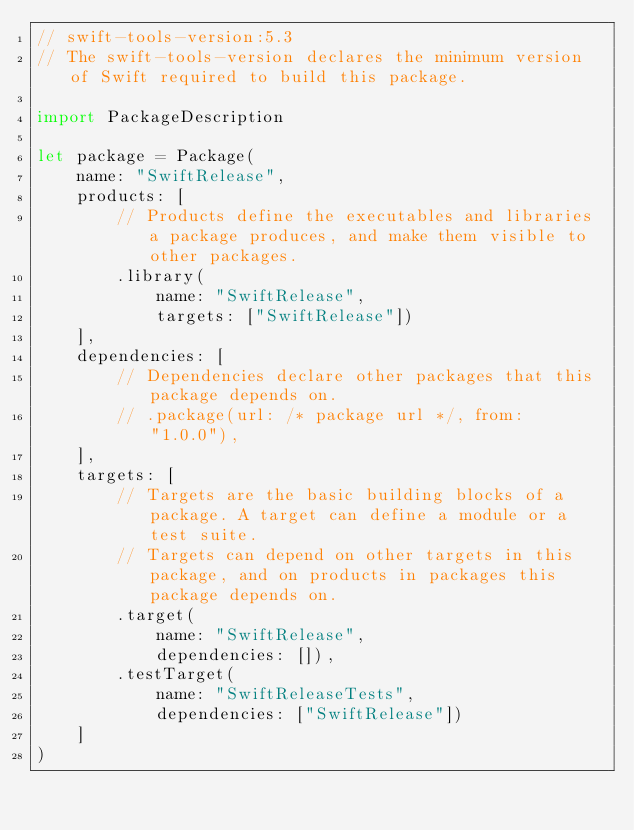Convert code to text. <code><loc_0><loc_0><loc_500><loc_500><_Swift_>// swift-tools-version:5.3
// The swift-tools-version declares the minimum version of Swift required to build this package.

import PackageDescription

let package = Package(
    name: "SwiftRelease",
    products: [
        // Products define the executables and libraries a package produces, and make them visible to other packages.
        .library(
            name: "SwiftRelease",
            targets: ["SwiftRelease"])
    ],
    dependencies: [
        // Dependencies declare other packages that this package depends on.
        // .package(url: /* package url */, from: "1.0.0"),
    ],
    targets: [
        // Targets are the basic building blocks of a package. A target can define a module or a test suite.
        // Targets can depend on other targets in this package, and on products in packages this package depends on.
        .target(
            name: "SwiftRelease",
            dependencies: []),
        .testTarget(
            name: "SwiftReleaseTests",
            dependencies: ["SwiftRelease"])
    ]
)
</code> 